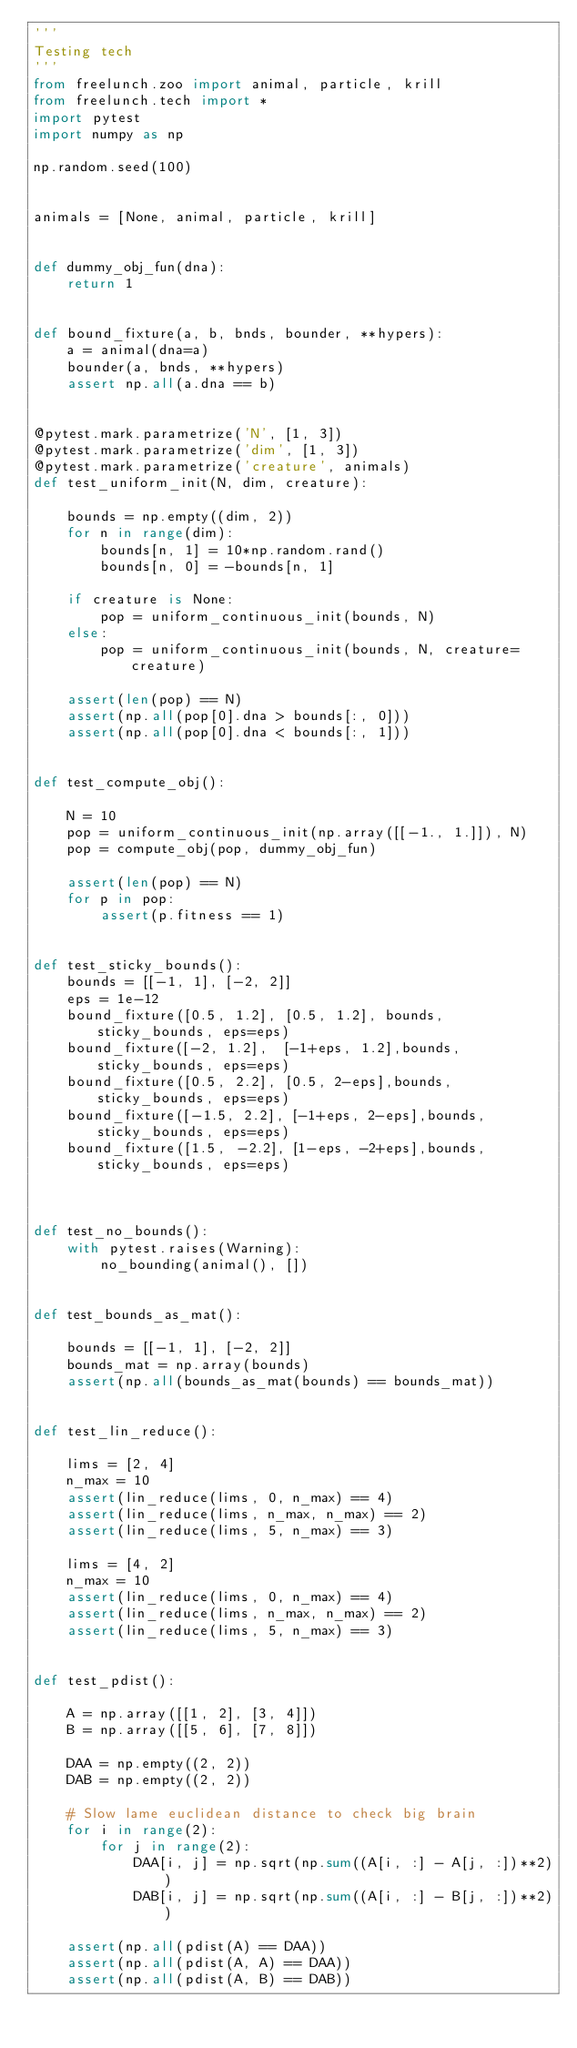Convert code to text. <code><loc_0><loc_0><loc_500><loc_500><_Python_>'''
Testing tech
'''
from freelunch.zoo import animal, particle, krill
from freelunch.tech import *
import pytest
import numpy as np

np.random.seed(100)


animals = [None, animal, particle, krill]


def dummy_obj_fun(dna):
    return 1


def bound_fixture(a, b, bnds, bounder, **hypers):
    a = animal(dna=a)
    bounder(a, bnds, **hypers)
    assert np.all(a.dna == b)


@pytest.mark.parametrize('N', [1, 3])
@pytest.mark.parametrize('dim', [1, 3])
@pytest.mark.parametrize('creature', animals)
def test_uniform_init(N, dim, creature):

    bounds = np.empty((dim, 2))
    for n in range(dim):
        bounds[n, 1] = 10*np.random.rand()
        bounds[n, 0] = -bounds[n, 1]

    if creature is None:
        pop = uniform_continuous_init(bounds, N)
    else:
        pop = uniform_continuous_init(bounds, N, creature=creature)

    assert(len(pop) == N)
    assert(np.all(pop[0].dna > bounds[:, 0]))
    assert(np.all(pop[0].dna < bounds[:, 1]))


def test_compute_obj():

    N = 10
    pop = uniform_continuous_init(np.array([[-1., 1.]]), N)
    pop = compute_obj(pop, dummy_obj_fun)

    assert(len(pop) == N)
    for p in pop:
        assert(p.fitness == 1)


def test_sticky_bounds():
    bounds = [[-1, 1], [-2, 2]]
    eps = 1e-12
    bound_fixture([0.5, 1.2], [0.5, 1.2], bounds, sticky_bounds, eps=eps)
    bound_fixture([-2, 1.2],  [-1+eps, 1.2],bounds, sticky_bounds, eps=eps)
    bound_fixture([0.5, 2.2], [0.5, 2-eps],bounds, sticky_bounds, eps=eps)
    bound_fixture([-1.5, 2.2], [-1+eps, 2-eps],bounds, sticky_bounds, eps=eps)
    bound_fixture([1.5, -2.2], [1-eps, -2+eps],bounds, sticky_bounds, eps=eps)



def test_no_bounds():
    with pytest.raises(Warning):
        no_bounding(animal(), [])


def test_bounds_as_mat():

    bounds = [[-1, 1], [-2, 2]]
    bounds_mat = np.array(bounds)
    assert(np.all(bounds_as_mat(bounds) == bounds_mat))


def test_lin_reduce():

    lims = [2, 4]
    n_max = 10
    assert(lin_reduce(lims, 0, n_max) == 4)
    assert(lin_reduce(lims, n_max, n_max) == 2)
    assert(lin_reduce(lims, 5, n_max) == 3)

    lims = [4, 2]
    n_max = 10
    assert(lin_reduce(lims, 0, n_max) == 4)
    assert(lin_reduce(lims, n_max, n_max) == 2)
    assert(lin_reduce(lims, 5, n_max) == 3)


def test_pdist():

    A = np.array([[1, 2], [3, 4]])
    B = np.array([[5, 6], [7, 8]])

    DAA = np.empty((2, 2))
    DAB = np.empty((2, 2))

    # Slow lame euclidean distance to check big brain
    for i in range(2):
        for j in range(2):
            DAA[i, j] = np.sqrt(np.sum((A[i, :] - A[j, :])**2))
            DAB[i, j] = np.sqrt(np.sum((A[i, :] - B[j, :])**2))

    assert(np.all(pdist(A) == DAA))
    assert(np.all(pdist(A, A) == DAA))
    assert(np.all(pdist(A, B) == DAB))
</code> 